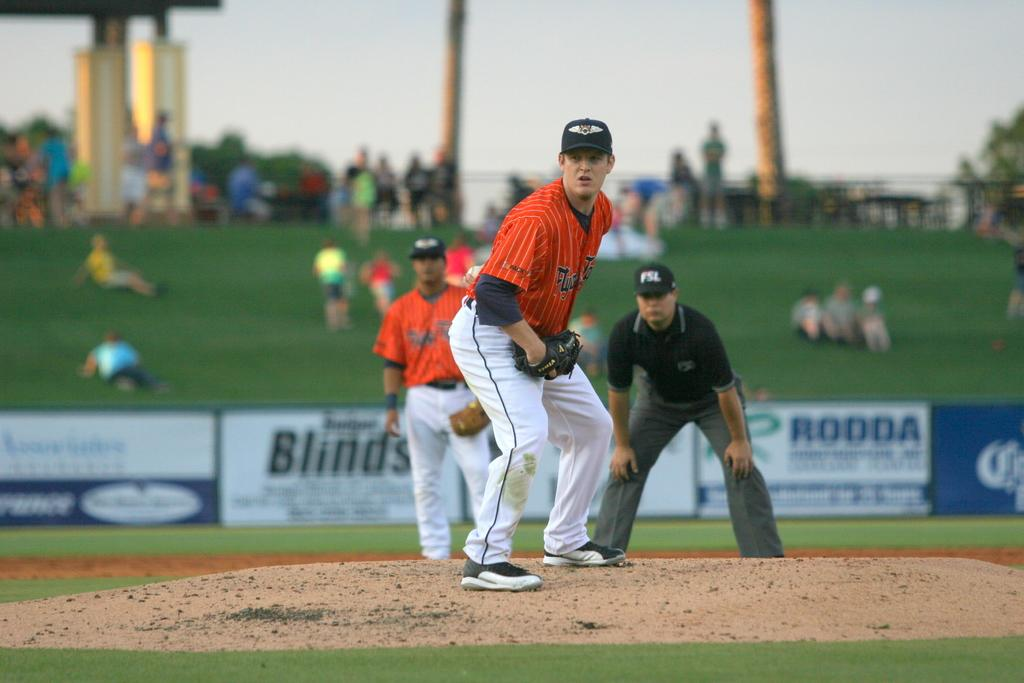<image>
Write a terse but informative summary of the picture. A baseball field displays a banner with RODDA on it. 